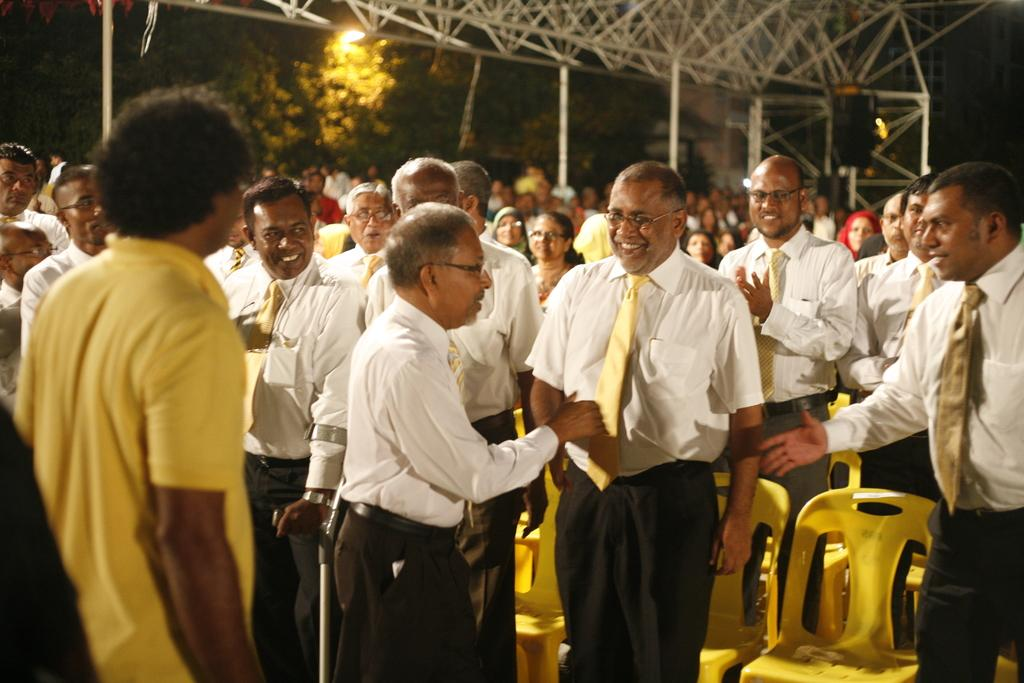What are the people in the image doing? The people in the image are standing on the floor. What objects can be seen in the background of the image? There are chairs, grills, and trees in the background of the image. What else is visible in the background of the image? The sky is visible in the background of the image. What is the price of the cake on the grill in the image? There is no cake or grill present in the image; it features people standing on the floor with chairs, trees, and the sky visible in the background. 